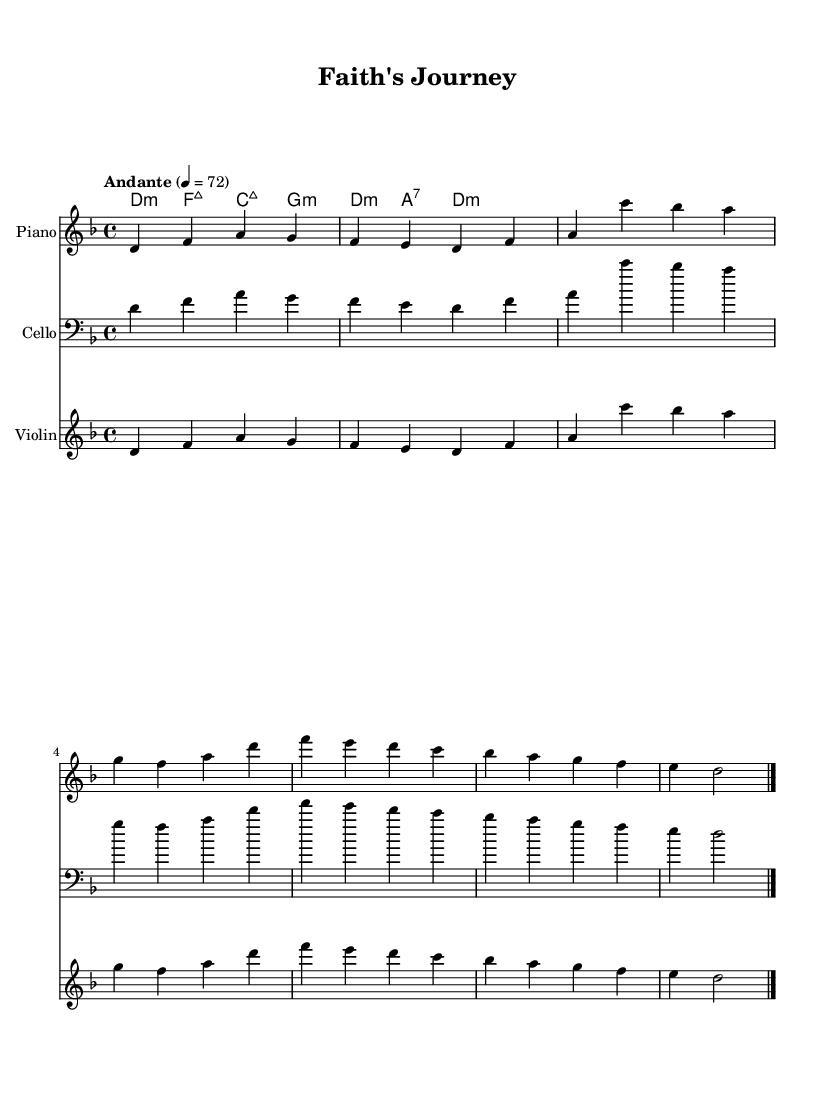What is the key signature of this music? The key signature is D minor, which has one flat. This can be identified by looking at the key indicated at the beginning of the sheet music.
Answer: D minor What is the time signature of this music? The time signature is 4/4, which can be found at the beginning of the score. It indicates that there are four beats in a measure, and a quarter note gets one beat.
Answer: 4/4 What is the tempo of this piece? The tempo is indicated as "Andante" with a metronome marking of 72 beats per minute. This is stated right at the beginning of the music.
Answer: Andante 4 = 72 How many measures are in the entire piece? There are eight measures. This can be determined by counting the vertical lines (bar lines) which indicate the end of each measure.
Answer: Eight What instruments are indicated in the score? The instruments listed are Piano, Cello, and Violin. These are specified at the beginning of each staff section in the score.
Answer: Piano, Cello, Violin What is the overall mood or theme of this piece of music? The music conveys a theme of faith and devotion as reflected in the lyrics. The emotional and lyrical content support a spiritual and uplifting atmosphere.
Answer: Faith and devotion Describe the harmonic structure of the piece. The harmonic structure is based on a chord progression featuring D minor, F major, C major, and G minor chords. This can be observed in the chord names notated above the melody.
Answer: D minor, F major, C major, G minor 